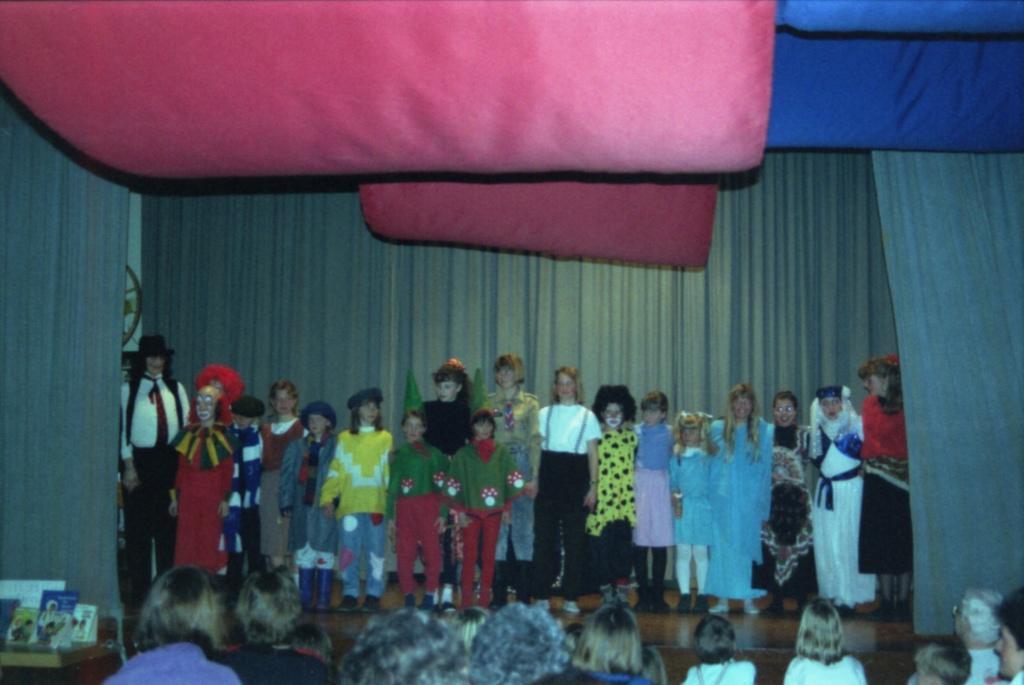Please provide a concise description of this image. In the foreground of this image, there are few people at the bottom and we can also see few brochure like objects on the table. In the middle, there are few people standing on the stage and we can also see few curtains. At the top, there is a red color and blue color object. 